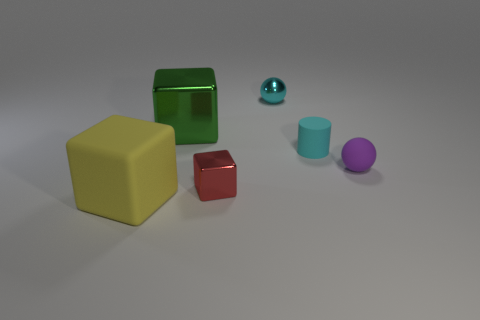Is the number of large green blocks in front of the tiny red block less than the number of big yellow rubber cubes that are in front of the yellow thing?
Offer a terse response. No. Do the tiny cyan object that is behind the big green block and the small matte thing that is to the right of the cyan cylinder have the same shape?
Your answer should be compact. Yes. There is a large thing to the right of the large thing in front of the tiny red thing; what shape is it?
Your answer should be compact. Cube. What is the size of the rubber thing that is the same color as the metal ball?
Your answer should be compact. Small. Is there a red thing made of the same material as the yellow object?
Your response must be concise. No. There is a big thing that is behind the purple object; what is its material?
Make the answer very short. Metal. What is the tiny cyan cylinder made of?
Your answer should be compact. Rubber. Does the big object in front of the large green cube have the same material as the red object?
Your answer should be very brief. No. Are there fewer cyan matte cylinders to the left of the red cube than small green metallic cubes?
Ensure brevity in your answer.  No. There is a metal thing that is the same size as the red cube; what is its color?
Ensure brevity in your answer.  Cyan. 